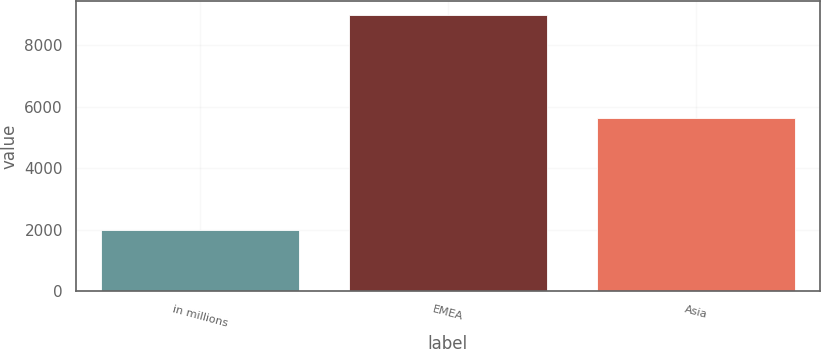Convert chart to OTSL. <chart><loc_0><loc_0><loc_500><loc_500><bar_chart><fcel>in millions<fcel>EMEA<fcel>Asia<nl><fcel>2015<fcel>8981<fcel>5637<nl></chart> 